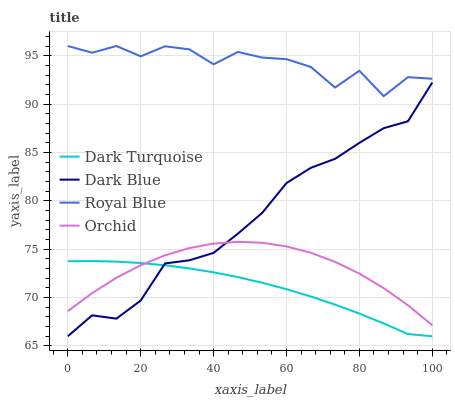Does Dark Turquoise have the minimum area under the curve?
Answer yes or no. Yes. Does Royal Blue have the maximum area under the curve?
Answer yes or no. Yes. Does Orchid have the minimum area under the curve?
Answer yes or no. No. Does Orchid have the maximum area under the curve?
Answer yes or no. No. Is Dark Turquoise the smoothest?
Answer yes or no. Yes. Is Royal Blue the roughest?
Answer yes or no. Yes. Is Orchid the smoothest?
Answer yes or no. No. Is Orchid the roughest?
Answer yes or no. No. Does Dark Turquoise have the lowest value?
Answer yes or no. Yes. Does Orchid have the lowest value?
Answer yes or no. No. Does Royal Blue have the highest value?
Answer yes or no. Yes. Does Orchid have the highest value?
Answer yes or no. No. Is Dark Turquoise less than Royal Blue?
Answer yes or no. Yes. Is Royal Blue greater than Dark Turquoise?
Answer yes or no. Yes. Does Orchid intersect Dark Turquoise?
Answer yes or no. Yes. Is Orchid less than Dark Turquoise?
Answer yes or no. No. Is Orchid greater than Dark Turquoise?
Answer yes or no. No. Does Dark Turquoise intersect Royal Blue?
Answer yes or no. No. 